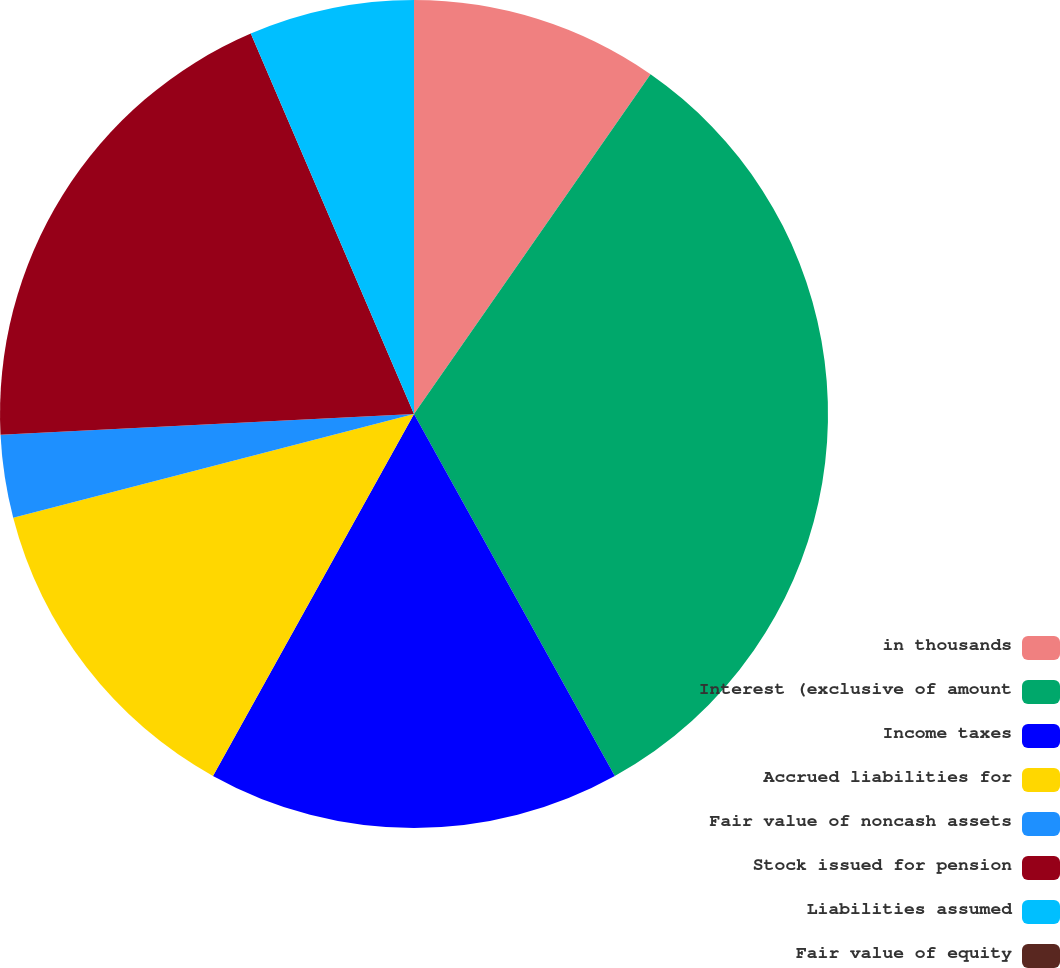Convert chart. <chart><loc_0><loc_0><loc_500><loc_500><pie_chart><fcel>in thousands<fcel>Interest (exclusive of amount<fcel>Income taxes<fcel>Accrued liabilities for<fcel>Fair value of noncash assets<fcel>Stock issued for pension<fcel>Liabilities assumed<fcel>Fair value of equity<nl><fcel>9.68%<fcel>32.26%<fcel>16.13%<fcel>12.9%<fcel>3.23%<fcel>19.35%<fcel>6.45%<fcel>0.0%<nl></chart> 